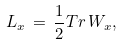<formula> <loc_0><loc_0><loc_500><loc_500>L _ { x } \, = \, \frac { 1 } { 2 } T r \, W _ { x } ,</formula> 